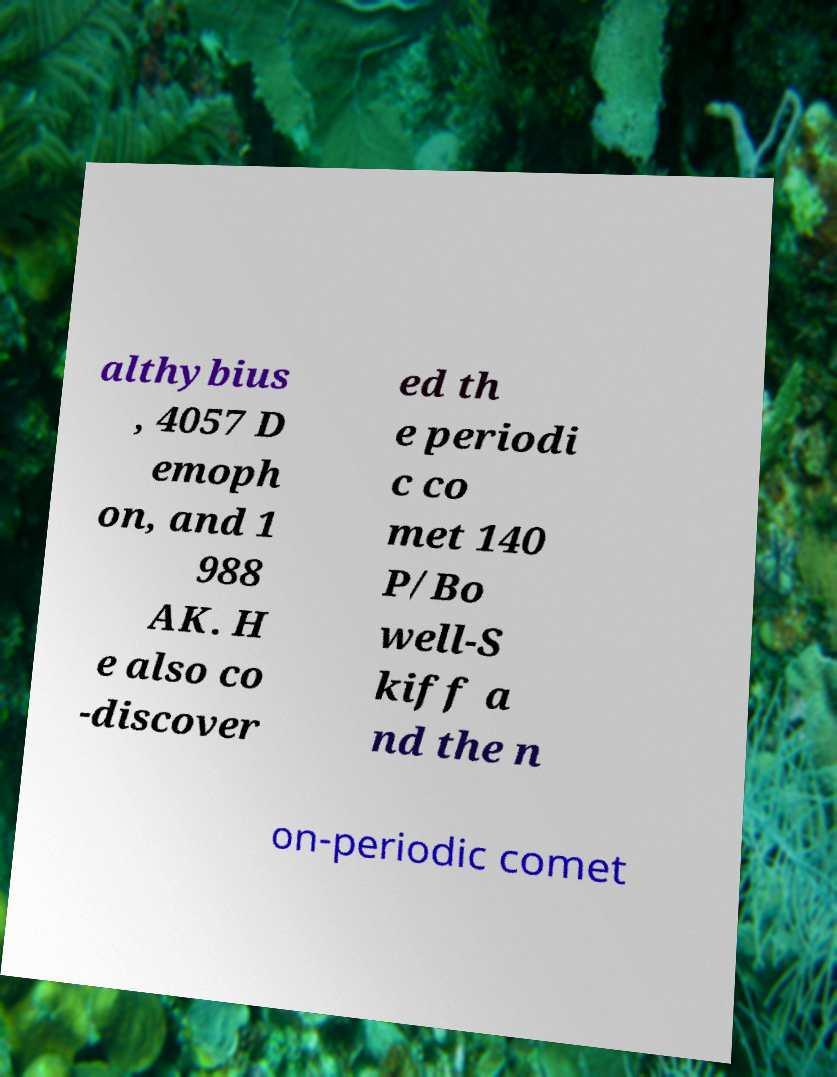I need the written content from this picture converted into text. Can you do that? althybius , 4057 D emoph on, and 1 988 AK. H e also co -discover ed th e periodi c co met 140 P/Bo well-S kiff a nd the n on-periodic comet 